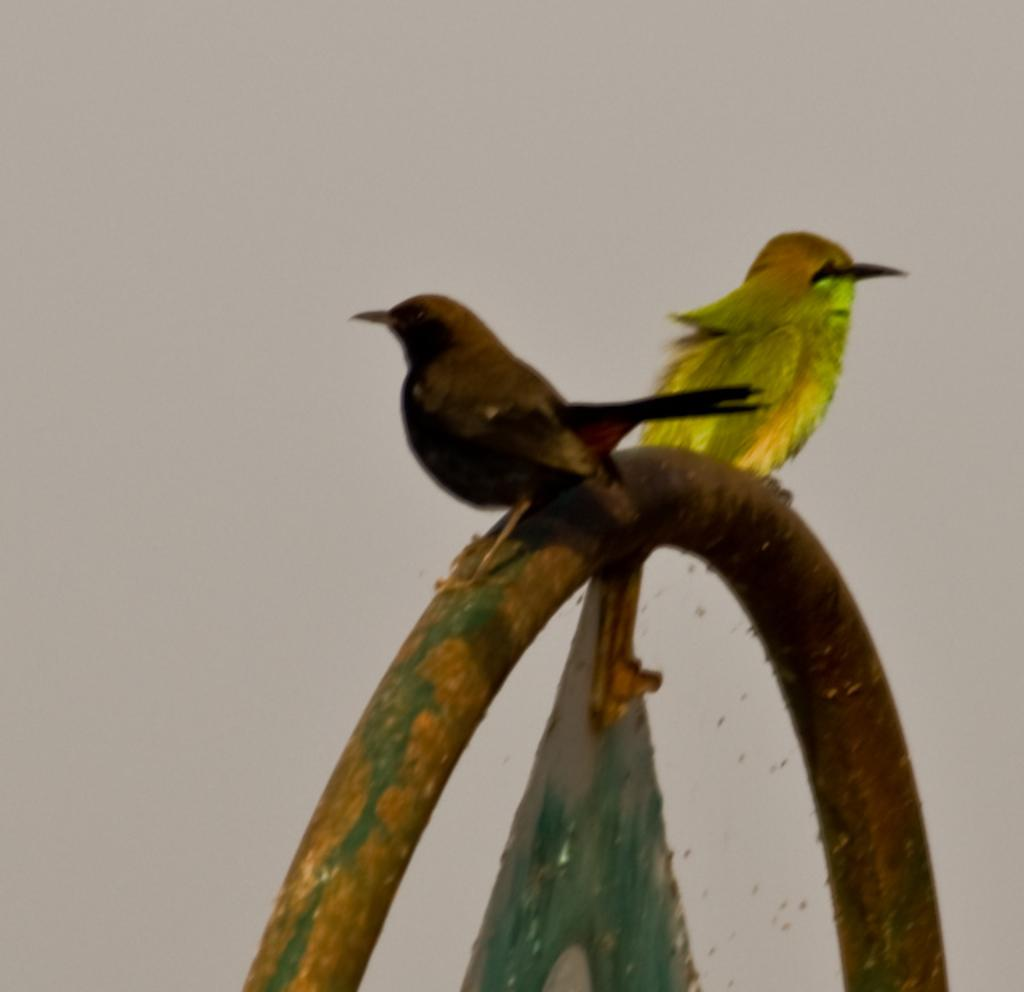How many birds are in the image? There are two birds in the image. Where are the birds located? The birds are on a circular iron pole. What type of development is taking place on the roof in the image? There is no roof or development present in the image; it features two birds on a circular iron pole. 